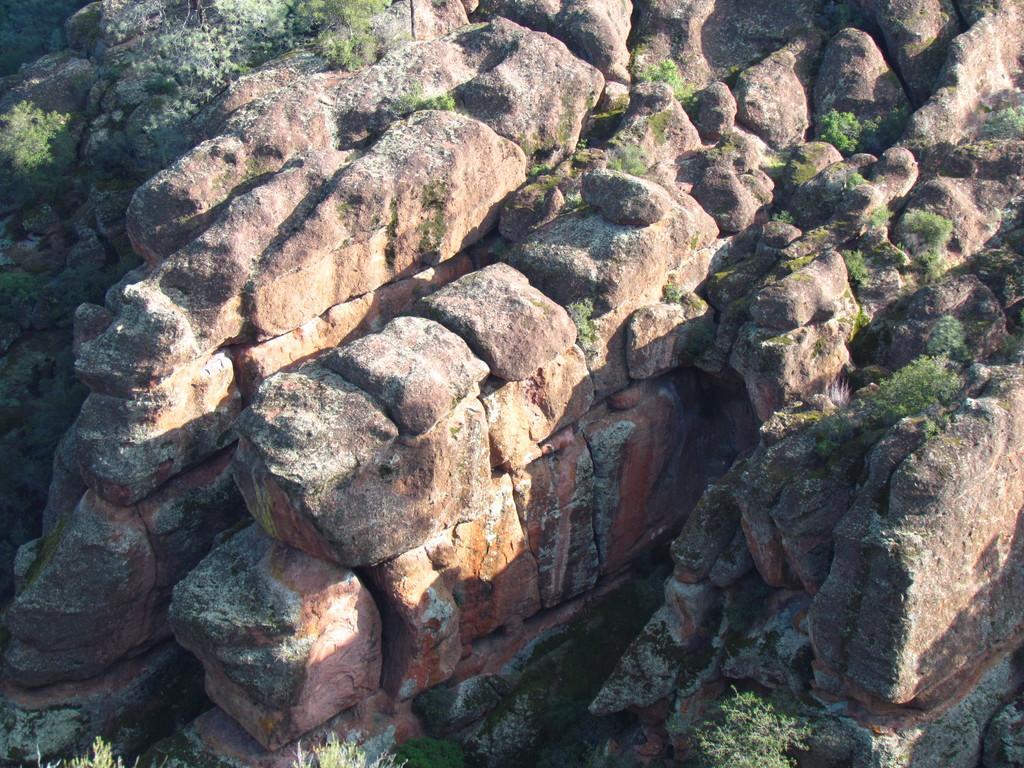Could you give a brief overview of what you see in this image? We can see stones and plants. 